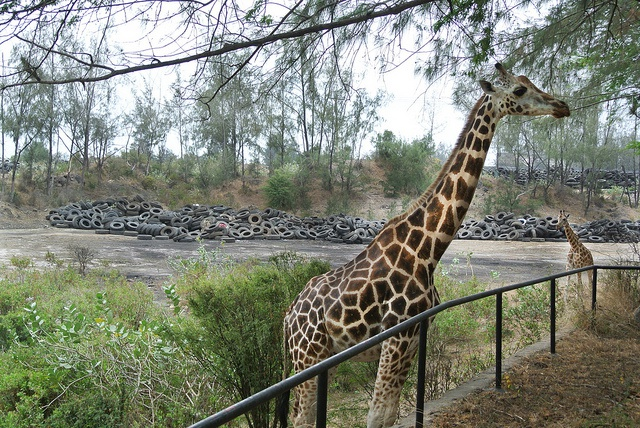Describe the objects in this image and their specific colors. I can see giraffe in gray, black, and maroon tones and giraffe in gray and darkgray tones in this image. 